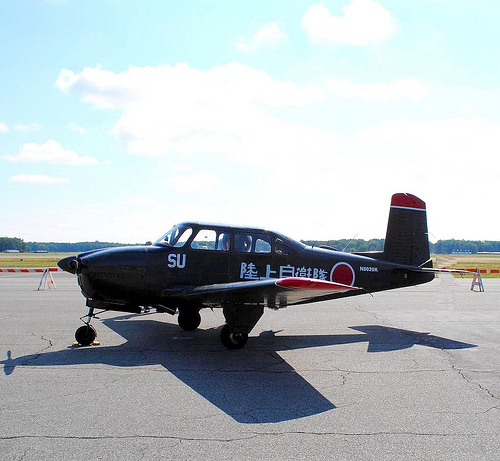Please provide a short description for this region: [0.42, 0.32, 0.52, 0.38]. In this region, white clouds are seen drifting across a blue sky, creating a picturesque and serene backdrop. 